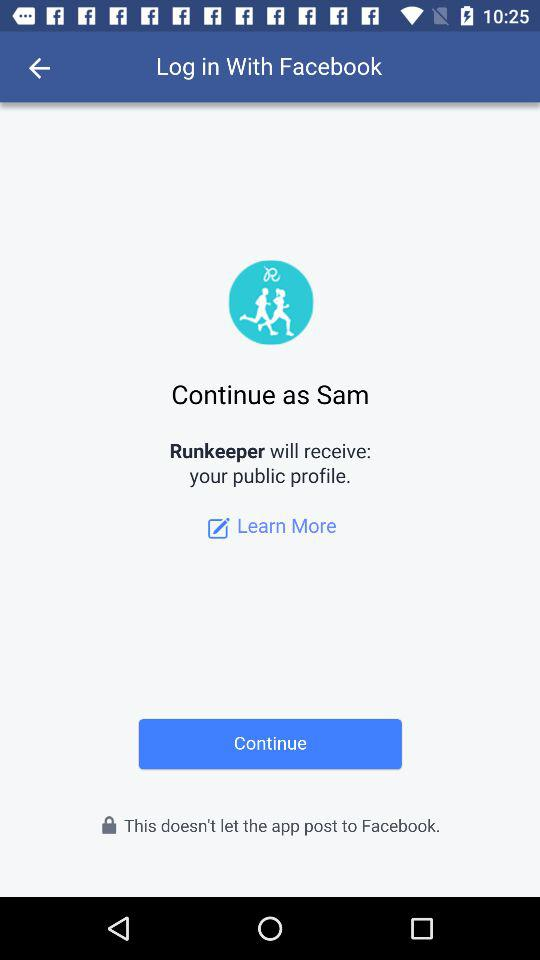Who will receive the public profile? The public profile will be received by "Runkeeper". 